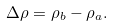Convert formula to latex. <formula><loc_0><loc_0><loc_500><loc_500>\Delta \rho = \rho _ { b } - \rho _ { a } .</formula> 